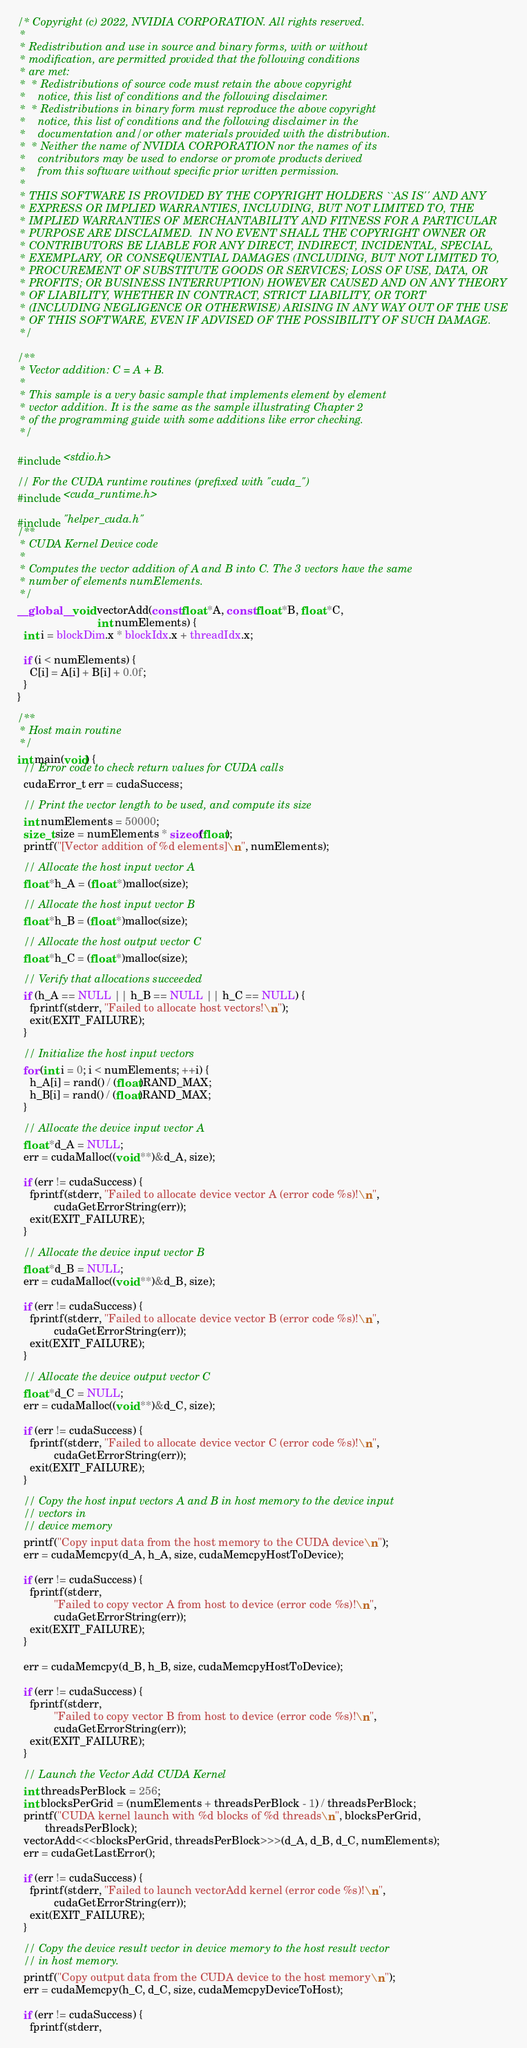Convert code to text. <code><loc_0><loc_0><loc_500><loc_500><_Cuda_>/* Copyright (c) 2022, NVIDIA CORPORATION. All rights reserved.
 *
 * Redistribution and use in source and binary forms, with or without
 * modification, are permitted provided that the following conditions
 * are met:
 *  * Redistributions of source code must retain the above copyright
 *    notice, this list of conditions and the following disclaimer.
 *  * Redistributions in binary form must reproduce the above copyright
 *    notice, this list of conditions and the following disclaimer in the
 *    documentation and/or other materials provided with the distribution.
 *  * Neither the name of NVIDIA CORPORATION nor the names of its
 *    contributors may be used to endorse or promote products derived
 *    from this software without specific prior written permission.
 *
 * THIS SOFTWARE IS PROVIDED BY THE COPYRIGHT HOLDERS ``AS IS'' AND ANY
 * EXPRESS OR IMPLIED WARRANTIES, INCLUDING, BUT NOT LIMITED TO, THE
 * IMPLIED WARRANTIES OF MERCHANTABILITY AND FITNESS FOR A PARTICULAR
 * PURPOSE ARE DISCLAIMED.  IN NO EVENT SHALL THE COPYRIGHT OWNER OR
 * CONTRIBUTORS BE LIABLE FOR ANY DIRECT, INDIRECT, INCIDENTAL, SPECIAL,
 * EXEMPLARY, OR CONSEQUENTIAL DAMAGES (INCLUDING, BUT NOT LIMITED TO,
 * PROCUREMENT OF SUBSTITUTE GOODS OR SERVICES; LOSS OF USE, DATA, OR
 * PROFITS; OR BUSINESS INTERRUPTION) HOWEVER CAUSED AND ON ANY THEORY
 * OF LIABILITY, WHETHER IN CONTRACT, STRICT LIABILITY, OR TORT
 * (INCLUDING NEGLIGENCE OR OTHERWISE) ARISING IN ANY WAY OUT OF THE USE
 * OF THIS SOFTWARE, EVEN IF ADVISED OF THE POSSIBILITY OF SUCH DAMAGE.
 */

/**
 * Vector addition: C = A + B.
 *
 * This sample is a very basic sample that implements element by element
 * vector addition. It is the same as the sample illustrating Chapter 2
 * of the programming guide with some additions like error checking.
 */

#include <stdio.h>

// For the CUDA runtime routines (prefixed with "cuda_")
#include <cuda_runtime.h>

#include "helper_cuda.h"
/**
 * CUDA Kernel Device code
 *
 * Computes the vector addition of A and B into C. The 3 vectors have the same
 * number of elements numElements.
 */
__global__ void vectorAdd(const float *A, const float *B, float *C,
                          int numElements) {
  int i = blockDim.x * blockIdx.x + threadIdx.x;

  if (i < numElements) {
    C[i] = A[i] + B[i] + 0.0f;
  }
}

/**
 * Host main routine
 */
int main(void) {
  // Error code to check return values for CUDA calls
  cudaError_t err = cudaSuccess;

  // Print the vector length to be used, and compute its size
  int numElements = 50000;
  size_t size = numElements * sizeof(float);
  printf("[Vector addition of %d elements]\n", numElements);

  // Allocate the host input vector A
  float *h_A = (float *)malloc(size);

  // Allocate the host input vector B
  float *h_B = (float *)malloc(size);

  // Allocate the host output vector C
  float *h_C = (float *)malloc(size);

  // Verify that allocations succeeded
  if (h_A == NULL || h_B == NULL || h_C == NULL) {
    fprintf(stderr, "Failed to allocate host vectors!\n");
    exit(EXIT_FAILURE);
  }

  // Initialize the host input vectors
  for (int i = 0; i < numElements; ++i) {
    h_A[i] = rand() / (float)RAND_MAX;
    h_B[i] = rand() / (float)RAND_MAX;
  }

  // Allocate the device input vector A
  float *d_A = NULL;
  err = cudaMalloc((void **)&d_A, size);

  if (err != cudaSuccess) {
    fprintf(stderr, "Failed to allocate device vector A (error code %s)!\n",
            cudaGetErrorString(err));
    exit(EXIT_FAILURE);
  }

  // Allocate the device input vector B
  float *d_B = NULL;
  err = cudaMalloc((void **)&d_B, size);

  if (err != cudaSuccess) {
    fprintf(stderr, "Failed to allocate device vector B (error code %s)!\n",
            cudaGetErrorString(err));
    exit(EXIT_FAILURE);
  }

  // Allocate the device output vector C
  float *d_C = NULL;
  err = cudaMalloc((void **)&d_C, size);

  if (err != cudaSuccess) {
    fprintf(stderr, "Failed to allocate device vector C (error code %s)!\n",
            cudaGetErrorString(err));
    exit(EXIT_FAILURE);
  }

  // Copy the host input vectors A and B in host memory to the device input
  // vectors in
  // device memory
  printf("Copy input data from the host memory to the CUDA device\n");
  err = cudaMemcpy(d_A, h_A, size, cudaMemcpyHostToDevice);

  if (err != cudaSuccess) {
    fprintf(stderr,
            "Failed to copy vector A from host to device (error code %s)!\n",
            cudaGetErrorString(err));
    exit(EXIT_FAILURE);
  }

  err = cudaMemcpy(d_B, h_B, size, cudaMemcpyHostToDevice);

  if (err != cudaSuccess) {
    fprintf(stderr,
            "Failed to copy vector B from host to device (error code %s)!\n",
            cudaGetErrorString(err));
    exit(EXIT_FAILURE);
  }

  // Launch the Vector Add CUDA Kernel
  int threadsPerBlock = 256;
  int blocksPerGrid = (numElements + threadsPerBlock - 1) / threadsPerBlock;
  printf("CUDA kernel launch with %d blocks of %d threads\n", blocksPerGrid,
         threadsPerBlock);
  vectorAdd<<<blocksPerGrid, threadsPerBlock>>>(d_A, d_B, d_C, numElements);
  err = cudaGetLastError();

  if (err != cudaSuccess) {
    fprintf(stderr, "Failed to launch vectorAdd kernel (error code %s)!\n",
            cudaGetErrorString(err));
    exit(EXIT_FAILURE);
  }

  // Copy the device result vector in device memory to the host result vector
  // in host memory.
  printf("Copy output data from the CUDA device to the host memory\n");
  err = cudaMemcpy(h_C, d_C, size, cudaMemcpyDeviceToHost);

  if (err != cudaSuccess) {
    fprintf(stderr,</code> 